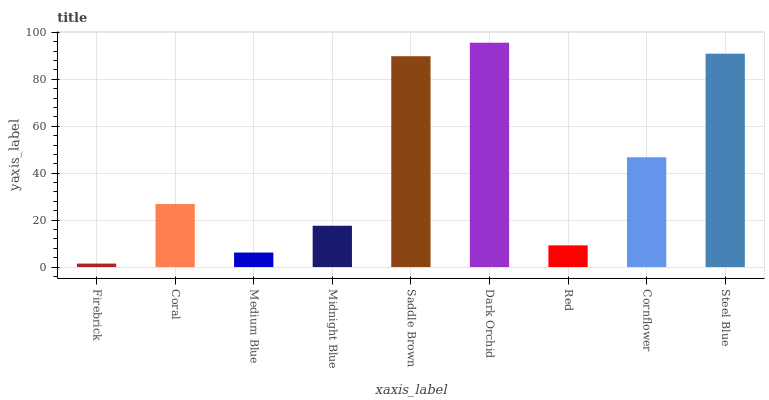Is Coral the minimum?
Answer yes or no. No. Is Coral the maximum?
Answer yes or no. No. Is Coral greater than Firebrick?
Answer yes or no. Yes. Is Firebrick less than Coral?
Answer yes or no. Yes. Is Firebrick greater than Coral?
Answer yes or no. No. Is Coral less than Firebrick?
Answer yes or no. No. Is Coral the high median?
Answer yes or no. Yes. Is Coral the low median?
Answer yes or no. Yes. Is Cornflower the high median?
Answer yes or no. No. Is Saddle Brown the low median?
Answer yes or no. No. 